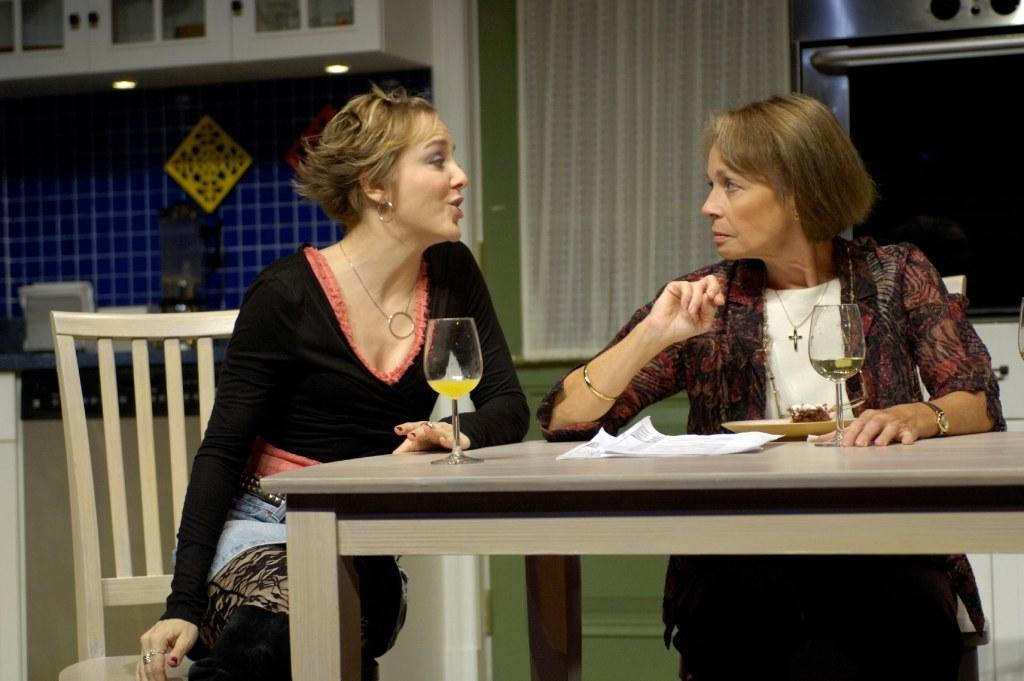How many people are sitting in front of the table in the image? There are two people sitting in front of the table in the image. What objects can be seen on the table? There are glasses, papers, and a plate on the table. What is located in the background of the image? There is a cupboard and a curtain in the background. Can you tell me how many cherries are on the plate in the image? There is no plate with cherries present in the image; the plate contains unspecified items. What type of squirrel can be seen climbing the cupboard in the image? There is no squirrel present in the image; the cupboard is in the background without any animals visible. 